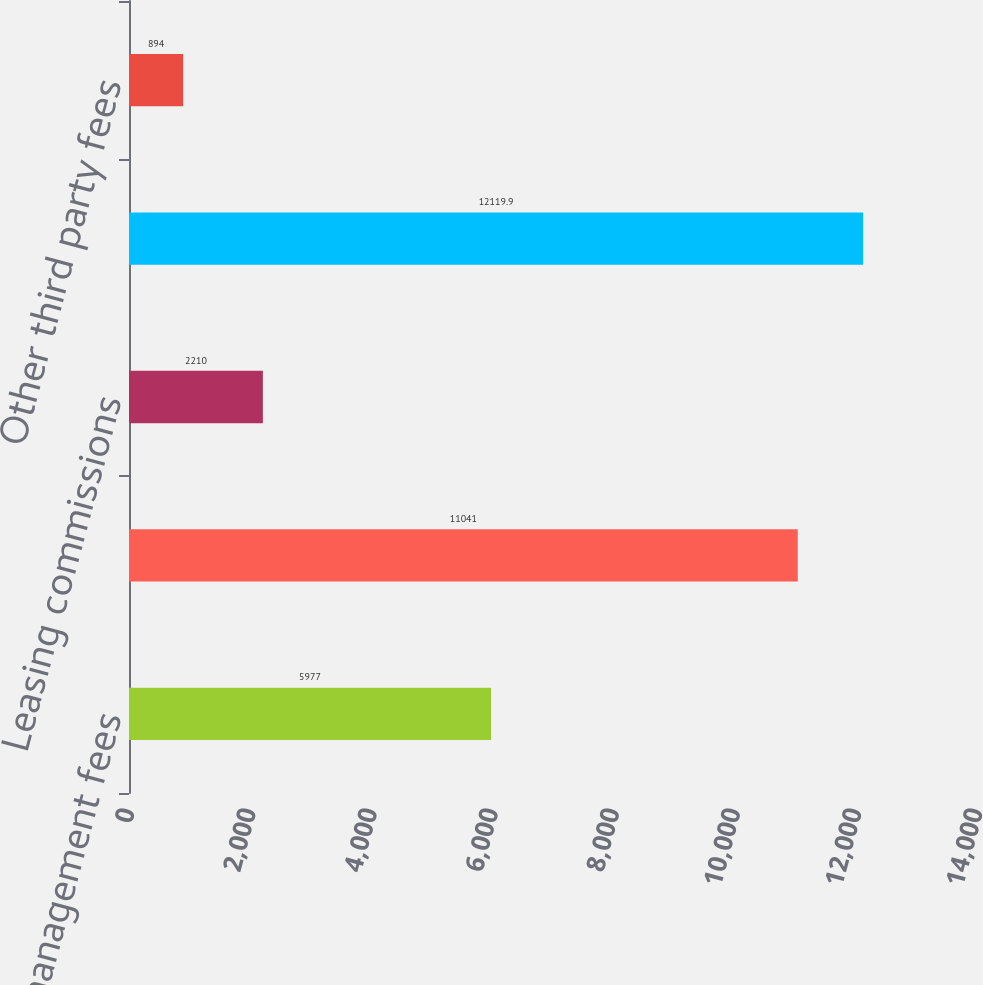Convert chart to OTSL. <chart><loc_0><loc_0><loc_500><loc_500><bar_chart><fcel>Asset management fees<fcel>Property management fees<fcel>Leasing commissions<fcel>Acquisition and financing fees<fcel>Other third party fees<nl><fcel>5977<fcel>11041<fcel>2210<fcel>12119.9<fcel>894<nl></chart> 